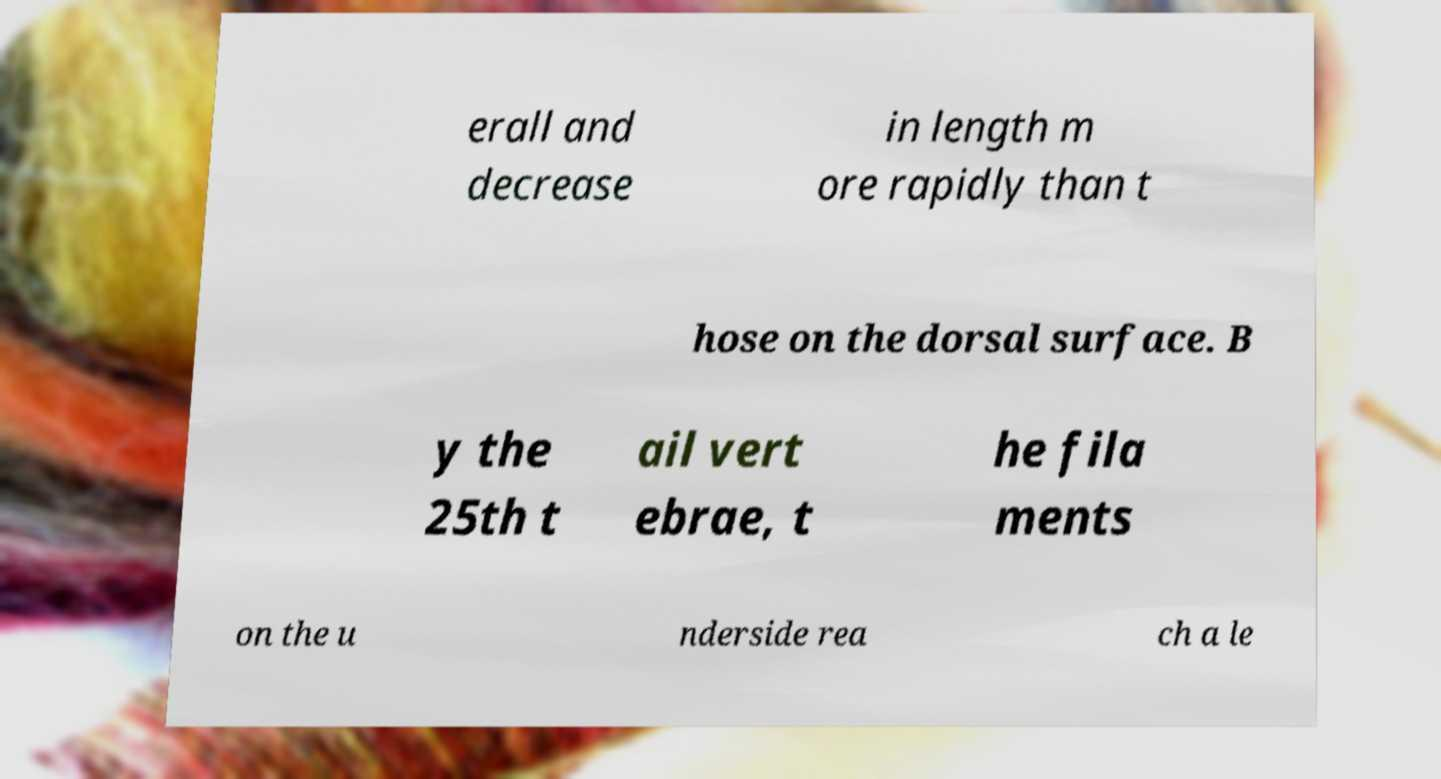Please identify and transcribe the text found in this image. erall and decrease in length m ore rapidly than t hose on the dorsal surface. B y the 25th t ail vert ebrae, t he fila ments on the u nderside rea ch a le 